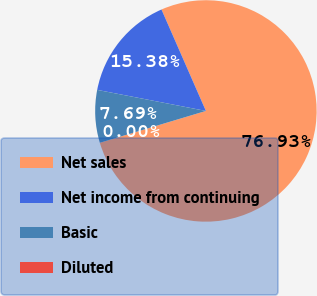Convert chart. <chart><loc_0><loc_0><loc_500><loc_500><pie_chart><fcel>Net sales<fcel>Net income from continuing<fcel>Basic<fcel>Diluted<nl><fcel>76.92%<fcel>15.38%<fcel>7.69%<fcel>0.0%<nl></chart> 